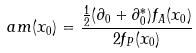<formula> <loc_0><loc_0><loc_500><loc_500>a m ( x _ { 0 } ) = \frac { \frac { 1 } { 2 } ( \partial _ { 0 } + \partial _ { 0 } ^ { * } ) f _ { A } ( x _ { 0 } ) } { 2 f _ { P } ( x _ { 0 } ) }</formula> 